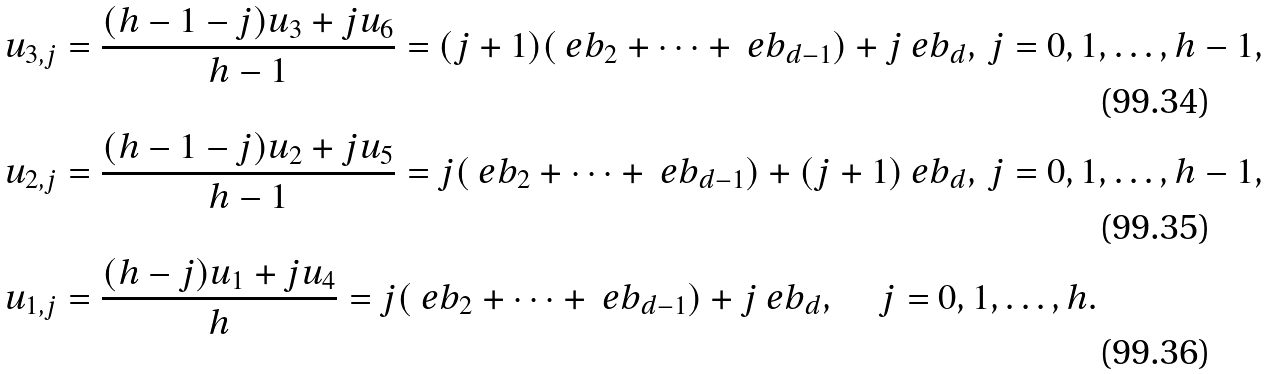Convert formula to latex. <formula><loc_0><loc_0><loc_500><loc_500>& u _ { 3 , j } = \frac { ( h - 1 - j ) u _ { 3 } + j u _ { 6 } } { h - 1 } = ( j + 1 ) ( \ e b _ { 2 } + \cdots + \ e b _ { d - 1 } ) + j \ e b _ { d } , \, j = 0 , 1 , \dots , h - 1 , \\ & u _ { 2 , j } = \frac { ( h - 1 - j ) u _ { 2 } + j u _ { 5 } } { h - 1 } = j ( \ e b _ { 2 } + \cdots + \ e b _ { d - 1 } ) + ( j + 1 ) \ e b _ { d } , \, j = 0 , 1 , \dots , h - 1 , \\ & u _ { 1 , j } = \frac { ( h - j ) u _ { 1 } + j u _ { 4 } } { h } = j ( \ e b _ { 2 } + \cdots + \ e b _ { d - 1 } ) + j \ e b _ { d } , \, \quad j = 0 , 1 , \dots , h .</formula> 